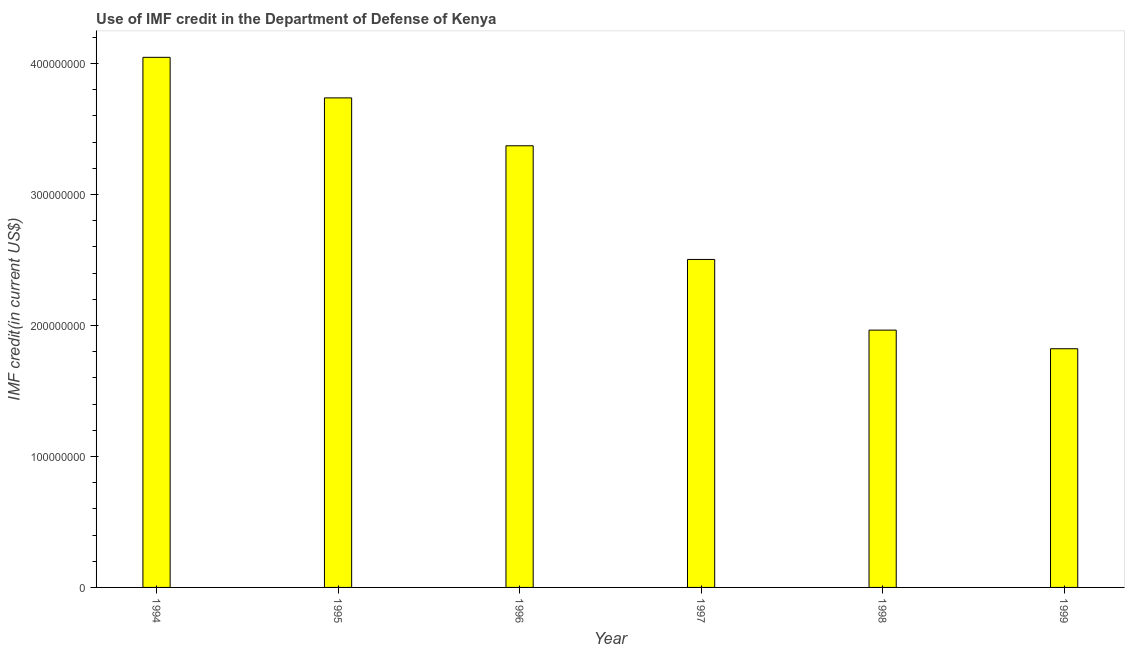Does the graph contain any zero values?
Your answer should be very brief. No. Does the graph contain grids?
Give a very brief answer. No. What is the title of the graph?
Provide a short and direct response. Use of IMF credit in the Department of Defense of Kenya. What is the label or title of the X-axis?
Make the answer very short. Year. What is the label or title of the Y-axis?
Your answer should be very brief. IMF credit(in current US$). What is the use of imf credit in dod in 1998?
Offer a very short reply. 1.96e+08. Across all years, what is the maximum use of imf credit in dod?
Provide a short and direct response. 4.05e+08. Across all years, what is the minimum use of imf credit in dod?
Provide a short and direct response. 1.82e+08. In which year was the use of imf credit in dod maximum?
Your answer should be very brief. 1994. What is the sum of the use of imf credit in dod?
Ensure brevity in your answer.  1.74e+09. What is the difference between the use of imf credit in dod in 1998 and 1999?
Offer a terse response. 1.42e+07. What is the average use of imf credit in dod per year?
Your response must be concise. 2.91e+08. What is the median use of imf credit in dod?
Offer a terse response. 2.94e+08. Do a majority of the years between 1999 and 1995 (inclusive) have use of imf credit in dod greater than 240000000 US$?
Offer a very short reply. Yes. What is the ratio of the use of imf credit in dod in 1994 to that in 1999?
Your answer should be compact. 2.22. Is the use of imf credit in dod in 1995 less than that in 1996?
Provide a short and direct response. No. What is the difference between the highest and the second highest use of imf credit in dod?
Offer a terse response. 3.10e+07. Is the sum of the use of imf credit in dod in 1994 and 1996 greater than the maximum use of imf credit in dod across all years?
Your answer should be compact. Yes. What is the difference between the highest and the lowest use of imf credit in dod?
Make the answer very short. 2.22e+08. What is the difference between two consecutive major ticks on the Y-axis?
Give a very brief answer. 1.00e+08. What is the IMF credit(in current US$) of 1994?
Your answer should be very brief. 4.05e+08. What is the IMF credit(in current US$) of 1995?
Make the answer very short. 3.74e+08. What is the IMF credit(in current US$) of 1996?
Make the answer very short. 3.37e+08. What is the IMF credit(in current US$) of 1997?
Offer a terse response. 2.50e+08. What is the IMF credit(in current US$) in 1998?
Ensure brevity in your answer.  1.96e+08. What is the IMF credit(in current US$) in 1999?
Provide a short and direct response. 1.82e+08. What is the difference between the IMF credit(in current US$) in 1994 and 1995?
Keep it short and to the point. 3.10e+07. What is the difference between the IMF credit(in current US$) in 1994 and 1996?
Your answer should be very brief. 6.75e+07. What is the difference between the IMF credit(in current US$) in 1994 and 1997?
Give a very brief answer. 1.54e+08. What is the difference between the IMF credit(in current US$) in 1994 and 1998?
Give a very brief answer. 2.08e+08. What is the difference between the IMF credit(in current US$) in 1994 and 1999?
Provide a short and direct response. 2.22e+08. What is the difference between the IMF credit(in current US$) in 1995 and 1996?
Make the answer very short. 3.66e+07. What is the difference between the IMF credit(in current US$) in 1995 and 1997?
Your response must be concise. 1.23e+08. What is the difference between the IMF credit(in current US$) in 1995 and 1998?
Provide a succinct answer. 1.77e+08. What is the difference between the IMF credit(in current US$) in 1995 and 1999?
Your answer should be compact. 1.92e+08. What is the difference between the IMF credit(in current US$) in 1996 and 1997?
Make the answer very short. 8.68e+07. What is the difference between the IMF credit(in current US$) in 1996 and 1998?
Your answer should be compact. 1.41e+08. What is the difference between the IMF credit(in current US$) in 1996 and 1999?
Your answer should be compact. 1.55e+08. What is the difference between the IMF credit(in current US$) in 1997 and 1998?
Offer a terse response. 5.40e+07. What is the difference between the IMF credit(in current US$) in 1997 and 1999?
Ensure brevity in your answer.  6.82e+07. What is the difference between the IMF credit(in current US$) in 1998 and 1999?
Your response must be concise. 1.42e+07. What is the ratio of the IMF credit(in current US$) in 1994 to that in 1995?
Provide a succinct answer. 1.08. What is the ratio of the IMF credit(in current US$) in 1994 to that in 1996?
Ensure brevity in your answer.  1.2. What is the ratio of the IMF credit(in current US$) in 1994 to that in 1997?
Your answer should be very brief. 1.62. What is the ratio of the IMF credit(in current US$) in 1994 to that in 1998?
Offer a very short reply. 2.06. What is the ratio of the IMF credit(in current US$) in 1994 to that in 1999?
Provide a short and direct response. 2.22. What is the ratio of the IMF credit(in current US$) in 1995 to that in 1996?
Make the answer very short. 1.11. What is the ratio of the IMF credit(in current US$) in 1995 to that in 1997?
Ensure brevity in your answer.  1.49. What is the ratio of the IMF credit(in current US$) in 1995 to that in 1998?
Offer a terse response. 1.9. What is the ratio of the IMF credit(in current US$) in 1995 to that in 1999?
Offer a terse response. 2.05. What is the ratio of the IMF credit(in current US$) in 1996 to that in 1997?
Offer a very short reply. 1.35. What is the ratio of the IMF credit(in current US$) in 1996 to that in 1998?
Offer a terse response. 1.72. What is the ratio of the IMF credit(in current US$) in 1996 to that in 1999?
Your answer should be compact. 1.85. What is the ratio of the IMF credit(in current US$) in 1997 to that in 1998?
Ensure brevity in your answer.  1.27. What is the ratio of the IMF credit(in current US$) in 1997 to that in 1999?
Give a very brief answer. 1.37. What is the ratio of the IMF credit(in current US$) in 1998 to that in 1999?
Make the answer very short. 1.08. 